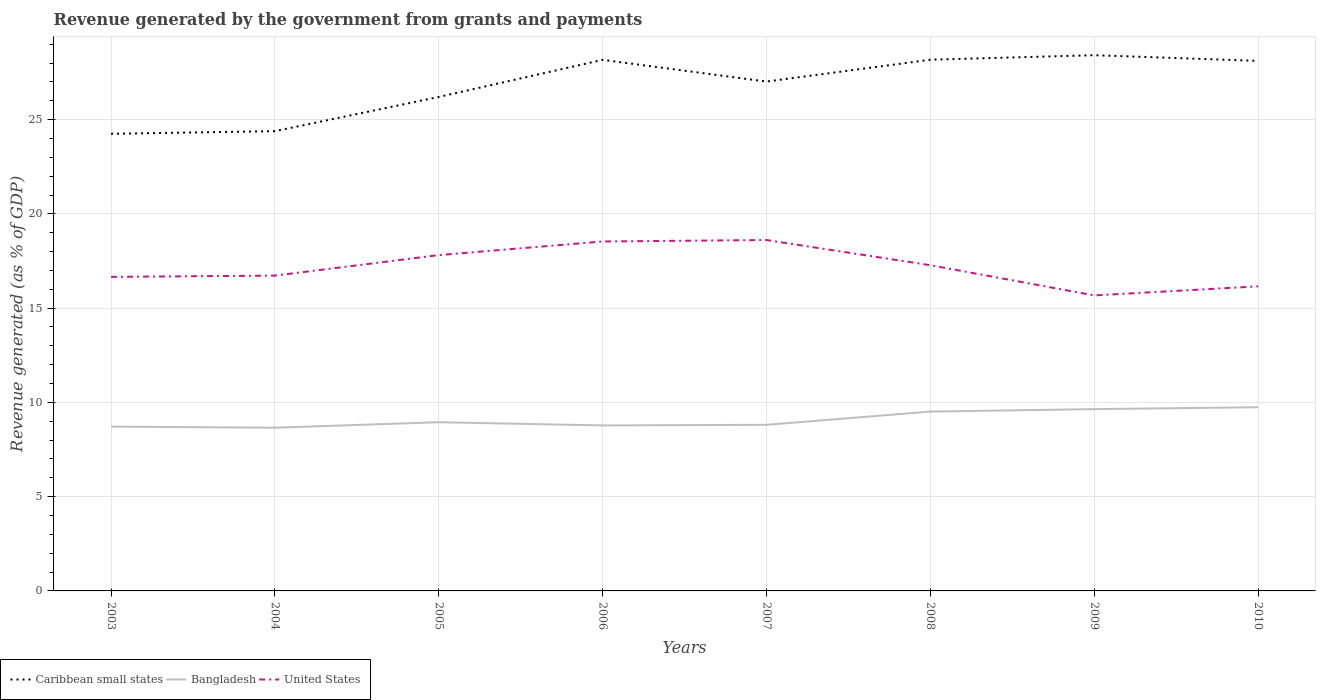How many different coloured lines are there?
Keep it short and to the point. 3. Does the line corresponding to United States intersect with the line corresponding to Caribbean small states?
Provide a short and direct response. No. Is the number of lines equal to the number of legend labels?
Make the answer very short. Yes. Across all years, what is the maximum revenue generated by the government in Caribbean small states?
Offer a very short reply. 24.25. In which year was the revenue generated by the government in Bangladesh maximum?
Ensure brevity in your answer.  2004. What is the total revenue generated by the government in Caribbean small states in the graph?
Your response must be concise. -2.77. What is the difference between the highest and the second highest revenue generated by the government in Bangladesh?
Your answer should be very brief. 1.09. How many years are there in the graph?
Your response must be concise. 8. Are the values on the major ticks of Y-axis written in scientific E-notation?
Provide a succinct answer. No. Does the graph contain any zero values?
Give a very brief answer. No. Where does the legend appear in the graph?
Your response must be concise. Bottom left. How many legend labels are there?
Your answer should be compact. 3. What is the title of the graph?
Give a very brief answer. Revenue generated by the government from grants and payments. What is the label or title of the X-axis?
Your answer should be compact. Years. What is the label or title of the Y-axis?
Give a very brief answer. Revenue generated (as % of GDP). What is the Revenue generated (as % of GDP) in Caribbean small states in 2003?
Provide a short and direct response. 24.25. What is the Revenue generated (as % of GDP) in Bangladesh in 2003?
Ensure brevity in your answer.  8.72. What is the Revenue generated (as % of GDP) in United States in 2003?
Make the answer very short. 16.66. What is the Revenue generated (as % of GDP) of Caribbean small states in 2004?
Keep it short and to the point. 24.39. What is the Revenue generated (as % of GDP) of Bangladesh in 2004?
Provide a short and direct response. 8.66. What is the Revenue generated (as % of GDP) in United States in 2004?
Make the answer very short. 16.73. What is the Revenue generated (as % of GDP) of Caribbean small states in 2005?
Make the answer very short. 26.2. What is the Revenue generated (as % of GDP) in Bangladesh in 2005?
Your response must be concise. 8.95. What is the Revenue generated (as % of GDP) in United States in 2005?
Offer a terse response. 17.81. What is the Revenue generated (as % of GDP) of Caribbean small states in 2006?
Offer a terse response. 28.17. What is the Revenue generated (as % of GDP) of Bangladesh in 2006?
Your answer should be compact. 8.78. What is the Revenue generated (as % of GDP) in United States in 2006?
Provide a succinct answer. 18.54. What is the Revenue generated (as % of GDP) in Caribbean small states in 2007?
Offer a terse response. 27.02. What is the Revenue generated (as % of GDP) of Bangladesh in 2007?
Your response must be concise. 8.81. What is the Revenue generated (as % of GDP) in United States in 2007?
Your answer should be very brief. 18.61. What is the Revenue generated (as % of GDP) of Caribbean small states in 2008?
Provide a succinct answer. 28.18. What is the Revenue generated (as % of GDP) of Bangladesh in 2008?
Make the answer very short. 9.51. What is the Revenue generated (as % of GDP) in United States in 2008?
Offer a terse response. 17.28. What is the Revenue generated (as % of GDP) of Caribbean small states in 2009?
Make the answer very short. 28.42. What is the Revenue generated (as % of GDP) in Bangladesh in 2009?
Offer a terse response. 9.64. What is the Revenue generated (as % of GDP) of United States in 2009?
Your answer should be very brief. 15.68. What is the Revenue generated (as % of GDP) of Caribbean small states in 2010?
Make the answer very short. 28.12. What is the Revenue generated (as % of GDP) of Bangladesh in 2010?
Make the answer very short. 9.74. What is the Revenue generated (as % of GDP) in United States in 2010?
Your response must be concise. 16.16. Across all years, what is the maximum Revenue generated (as % of GDP) of Caribbean small states?
Provide a short and direct response. 28.42. Across all years, what is the maximum Revenue generated (as % of GDP) in Bangladesh?
Offer a terse response. 9.74. Across all years, what is the maximum Revenue generated (as % of GDP) in United States?
Provide a short and direct response. 18.61. Across all years, what is the minimum Revenue generated (as % of GDP) of Caribbean small states?
Your answer should be very brief. 24.25. Across all years, what is the minimum Revenue generated (as % of GDP) of Bangladesh?
Your answer should be very brief. 8.66. Across all years, what is the minimum Revenue generated (as % of GDP) in United States?
Offer a very short reply. 15.68. What is the total Revenue generated (as % of GDP) of Caribbean small states in the graph?
Your response must be concise. 214.74. What is the total Revenue generated (as % of GDP) in Bangladesh in the graph?
Ensure brevity in your answer.  72.81. What is the total Revenue generated (as % of GDP) of United States in the graph?
Ensure brevity in your answer.  137.45. What is the difference between the Revenue generated (as % of GDP) in Caribbean small states in 2003 and that in 2004?
Your response must be concise. -0.14. What is the difference between the Revenue generated (as % of GDP) of Bangladesh in 2003 and that in 2004?
Provide a succinct answer. 0.06. What is the difference between the Revenue generated (as % of GDP) of United States in 2003 and that in 2004?
Your response must be concise. -0.07. What is the difference between the Revenue generated (as % of GDP) in Caribbean small states in 2003 and that in 2005?
Your response must be concise. -1.96. What is the difference between the Revenue generated (as % of GDP) of Bangladesh in 2003 and that in 2005?
Make the answer very short. -0.23. What is the difference between the Revenue generated (as % of GDP) in United States in 2003 and that in 2005?
Make the answer very short. -1.15. What is the difference between the Revenue generated (as % of GDP) in Caribbean small states in 2003 and that in 2006?
Ensure brevity in your answer.  -3.92. What is the difference between the Revenue generated (as % of GDP) in Bangladesh in 2003 and that in 2006?
Provide a succinct answer. -0.06. What is the difference between the Revenue generated (as % of GDP) of United States in 2003 and that in 2006?
Provide a short and direct response. -1.88. What is the difference between the Revenue generated (as % of GDP) of Caribbean small states in 2003 and that in 2007?
Keep it short and to the point. -2.77. What is the difference between the Revenue generated (as % of GDP) in Bangladesh in 2003 and that in 2007?
Ensure brevity in your answer.  -0.1. What is the difference between the Revenue generated (as % of GDP) in United States in 2003 and that in 2007?
Provide a succinct answer. -1.95. What is the difference between the Revenue generated (as % of GDP) of Caribbean small states in 2003 and that in 2008?
Provide a succinct answer. -3.93. What is the difference between the Revenue generated (as % of GDP) of Bangladesh in 2003 and that in 2008?
Your answer should be compact. -0.8. What is the difference between the Revenue generated (as % of GDP) in United States in 2003 and that in 2008?
Offer a terse response. -0.62. What is the difference between the Revenue generated (as % of GDP) of Caribbean small states in 2003 and that in 2009?
Ensure brevity in your answer.  -4.17. What is the difference between the Revenue generated (as % of GDP) in Bangladesh in 2003 and that in 2009?
Keep it short and to the point. -0.93. What is the difference between the Revenue generated (as % of GDP) of Caribbean small states in 2003 and that in 2010?
Keep it short and to the point. -3.87. What is the difference between the Revenue generated (as % of GDP) in Bangladesh in 2003 and that in 2010?
Offer a very short reply. -1.03. What is the difference between the Revenue generated (as % of GDP) of United States in 2003 and that in 2010?
Provide a short and direct response. 0.5. What is the difference between the Revenue generated (as % of GDP) in Caribbean small states in 2004 and that in 2005?
Provide a succinct answer. -1.82. What is the difference between the Revenue generated (as % of GDP) of Bangladesh in 2004 and that in 2005?
Provide a short and direct response. -0.29. What is the difference between the Revenue generated (as % of GDP) of United States in 2004 and that in 2005?
Provide a short and direct response. -1.09. What is the difference between the Revenue generated (as % of GDP) of Caribbean small states in 2004 and that in 2006?
Offer a terse response. -3.78. What is the difference between the Revenue generated (as % of GDP) of Bangladesh in 2004 and that in 2006?
Ensure brevity in your answer.  -0.12. What is the difference between the Revenue generated (as % of GDP) of United States in 2004 and that in 2006?
Keep it short and to the point. -1.81. What is the difference between the Revenue generated (as % of GDP) of Caribbean small states in 2004 and that in 2007?
Keep it short and to the point. -2.63. What is the difference between the Revenue generated (as % of GDP) in Bangladesh in 2004 and that in 2007?
Give a very brief answer. -0.15. What is the difference between the Revenue generated (as % of GDP) of United States in 2004 and that in 2007?
Your response must be concise. -1.89. What is the difference between the Revenue generated (as % of GDP) in Caribbean small states in 2004 and that in 2008?
Provide a short and direct response. -3.79. What is the difference between the Revenue generated (as % of GDP) in Bangladesh in 2004 and that in 2008?
Offer a terse response. -0.86. What is the difference between the Revenue generated (as % of GDP) of United States in 2004 and that in 2008?
Keep it short and to the point. -0.55. What is the difference between the Revenue generated (as % of GDP) of Caribbean small states in 2004 and that in 2009?
Your answer should be compact. -4.03. What is the difference between the Revenue generated (as % of GDP) in Bangladesh in 2004 and that in 2009?
Make the answer very short. -0.99. What is the difference between the Revenue generated (as % of GDP) of United States in 2004 and that in 2009?
Your answer should be compact. 1.05. What is the difference between the Revenue generated (as % of GDP) in Caribbean small states in 2004 and that in 2010?
Ensure brevity in your answer.  -3.73. What is the difference between the Revenue generated (as % of GDP) in Bangladesh in 2004 and that in 2010?
Your answer should be very brief. -1.09. What is the difference between the Revenue generated (as % of GDP) in United States in 2004 and that in 2010?
Your answer should be compact. 0.57. What is the difference between the Revenue generated (as % of GDP) of Caribbean small states in 2005 and that in 2006?
Your answer should be compact. -1.97. What is the difference between the Revenue generated (as % of GDP) in Bangladesh in 2005 and that in 2006?
Ensure brevity in your answer.  0.17. What is the difference between the Revenue generated (as % of GDP) in United States in 2005 and that in 2006?
Ensure brevity in your answer.  -0.72. What is the difference between the Revenue generated (as % of GDP) in Caribbean small states in 2005 and that in 2007?
Your answer should be compact. -0.81. What is the difference between the Revenue generated (as % of GDP) of Bangladesh in 2005 and that in 2007?
Provide a short and direct response. 0.14. What is the difference between the Revenue generated (as % of GDP) in United States in 2005 and that in 2007?
Offer a very short reply. -0.8. What is the difference between the Revenue generated (as % of GDP) in Caribbean small states in 2005 and that in 2008?
Your answer should be compact. -1.97. What is the difference between the Revenue generated (as % of GDP) of Bangladesh in 2005 and that in 2008?
Make the answer very short. -0.56. What is the difference between the Revenue generated (as % of GDP) in United States in 2005 and that in 2008?
Your answer should be compact. 0.54. What is the difference between the Revenue generated (as % of GDP) in Caribbean small states in 2005 and that in 2009?
Keep it short and to the point. -2.21. What is the difference between the Revenue generated (as % of GDP) in Bangladesh in 2005 and that in 2009?
Provide a short and direct response. -0.69. What is the difference between the Revenue generated (as % of GDP) of United States in 2005 and that in 2009?
Your answer should be compact. 2.14. What is the difference between the Revenue generated (as % of GDP) of Caribbean small states in 2005 and that in 2010?
Your response must be concise. -1.91. What is the difference between the Revenue generated (as % of GDP) of Bangladesh in 2005 and that in 2010?
Your answer should be very brief. -0.79. What is the difference between the Revenue generated (as % of GDP) in United States in 2005 and that in 2010?
Your answer should be compact. 1.66. What is the difference between the Revenue generated (as % of GDP) of Caribbean small states in 2006 and that in 2007?
Your answer should be very brief. 1.15. What is the difference between the Revenue generated (as % of GDP) of Bangladesh in 2006 and that in 2007?
Your answer should be compact. -0.03. What is the difference between the Revenue generated (as % of GDP) in United States in 2006 and that in 2007?
Keep it short and to the point. -0.08. What is the difference between the Revenue generated (as % of GDP) of Caribbean small states in 2006 and that in 2008?
Your answer should be very brief. -0.01. What is the difference between the Revenue generated (as % of GDP) in Bangladesh in 2006 and that in 2008?
Give a very brief answer. -0.73. What is the difference between the Revenue generated (as % of GDP) of United States in 2006 and that in 2008?
Your answer should be very brief. 1.26. What is the difference between the Revenue generated (as % of GDP) of Caribbean small states in 2006 and that in 2009?
Keep it short and to the point. -0.25. What is the difference between the Revenue generated (as % of GDP) of Bangladesh in 2006 and that in 2009?
Your answer should be very brief. -0.86. What is the difference between the Revenue generated (as % of GDP) in United States in 2006 and that in 2009?
Your response must be concise. 2.86. What is the difference between the Revenue generated (as % of GDP) in Caribbean small states in 2006 and that in 2010?
Ensure brevity in your answer.  0.05. What is the difference between the Revenue generated (as % of GDP) of Bangladesh in 2006 and that in 2010?
Offer a very short reply. -0.97. What is the difference between the Revenue generated (as % of GDP) in United States in 2006 and that in 2010?
Give a very brief answer. 2.38. What is the difference between the Revenue generated (as % of GDP) of Caribbean small states in 2007 and that in 2008?
Offer a very short reply. -1.16. What is the difference between the Revenue generated (as % of GDP) in Bangladesh in 2007 and that in 2008?
Offer a terse response. -0.7. What is the difference between the Revenue generated (as % of GDP) of United States in 2007 and that in 2008?
Your response must be concise. 1.34. What is the difference between the Revenue generated (as % of GDP) in Caribbean small states in 2007 and that in 2009?
Ensure brevity in your answer.  -1.4. What is the difference between the Revenue generated (as % of GDP) in Bangladesh in 2007 and that in 2009?
Give a very brief answer. -0.83. What is the difference between the Revenue generated (as % of GDP) in United States in 2007 and that in 2009?
Give a very brief answer. 2.94. What is the difference between the Revenue generated (as % of GDP) in Caribbean small states in 2007 and that in 2010?
Provide a succinct answer. -1.1. What is the difference between the Revenue generated (as % of GDP) of Bangladesh in 2007 and that in 2010?
Your answer should be very brief. -0.93. What is the difference between the Revenue generated (as % of GDP) in United States in 2007 and that in 2010?
Provide a short and direct response. 2.46. What is the difference between the Revenue generated (as % of GDP) of Caribbean small states in 2008 and that in 2009?
Give a very brief answer. -0.24. What is the difference between the Revenue generated (as % of GDP) in Bangladesh in 2008 and that in 2009?
Offer a very short reply. -0.13. What is the difference between the Revenue generated (as % of GDP) of United States in 2008 and that in 2009?
Your response must be concise. 1.6. What is the difference between the Revenue generated (as % of GDP) of Caribbean small states in 2008 and that in 2010?
Your answer should be very brief. 0.06. What is the difference between the Revenue generated (as % of GDP) in Bangladesh in 2008 and that in 2010?
Give a very brief answer. -0.23. What is the difference between the Revenue generated (as % of GDP) of United States in 2008 and that in 2010?
Give a very brief answer. 1.12. What is the difference between the Revenue generated (as % of GDP) in Caribbean small states in 2009 and that in 2010?
Give a very brief answer. 0.3. What is the difference between the Revenue generated (as % of GDP) in Bangladesh in 2009 and that in 2010?
Provide a short and direct response. -0.1. What is the difference between the Revenue generated (as % of GDP) of United States in 2009 and that in 2010?
Offer a terse response. -0.48. What is the difference between the Revenue generated (as % of GDP) of Caribbean small states in 2003 and the Revenue generated (as % of GDP) of Bangladesh in 2004?
Make the answer very short. 15.59. What is the difference between the Revenue generated (as % of GDP) of Caribbean small states in 2003 and the Revenue generated (as % of GDP) of United States in 2004?
Ensure brevity in your answer.  7.52. What is the difference between the Revenue generated (as % of GDP) in Bangladesh in 2003 and the Revenue generated (as % of GDP) in United States in 2004?
Your answer should be compact. -8.01. What is the difference between the Revenue generated (as % of GDP) in Caribbean small states in 2003 and the Revenue generated (as % of GDP) in Bangladesh in 2005?
Your answer should be very brief. 15.3. What is the difference between the Revenue generated (as % of GDP) of Caribbean small states in 2003 and the Revenue generated (as % of GDP) of United States in 2005?
Your response must be concise. 6.44. What is the difference between the Revenue generated (as % of GDP) in Bangladesh in 2003 and the Revenue generated (as % of GDP) in United States in 2005?
Provide a succinct answer. -9.1. What is the difference between the Revenue generated (as % of GDP) of Caribbean small states in 2003 and the Revenue generated (as % of GDP) of Bangladesh in 2006?
Provide a succinct answer. 15.47. What is the difference between the Revenue generated (as % of GDP) in Caribbean small states in 2003 and the Revenue generated (as % of GDP) in United States in 2006?
Ensure brevity in your answer.  5.71. What is the difference between the Revenue generated (as % of GDP) of Bangladesh in 2003 and the Revenue generated (as % of GDP) of United States in 2006?
Ensure brevity in your answer.  -9.82. What is the difference between the Revenue generated (as % of GDP) of Caribbean small states in 2003 and the Revenue generated (as % of GDP) of Bangladesh in 2007?
Ensure brevity in your answer.  15.44. What is the difference between the Revenue generated (as % of GDP) in Caribbean small states in 2003 and the Revenue generated (as % of GDP) in United States in 2007?
Your answer should be compact. 5.64. What is the difference between the Revenue generated (as % of GDP) of Bangladesh in 2003 and the Revenue generated (as % of GDP) of United States in 2007?
Provide a short and direct response. -9.9. What is the difference between the Revenue generated (as % of GDP) of Caribbean small states in 2003 and the Revenue generated (as % of GDP) of Bangladesh in 2008?
Give a very brief answer. 14.74. What is the difference between the Revenue generated (as % of GDP) of Caribbean small states in 2003 and the Revenue generated (as % of GDP) of United States in 2008?
Offer a terse response. 6.97. What is the difference between the Revenue generated (as % of GDP) in Bangladesh in 2003 and the Revenue generated (as % of GDP) in United States in 2008?
Provide a short and direct response. -8.56. What is the difference between the Revenue generated (as % of GDP) in Caribbean small states in 2003 and the Revenue generated (as % of GDP) in Bangladesh in 2009?
Offer a very short reply. 14.61. What is the difference between the Revenue generated (as % of GDP) in Caribbean small states in 2003 and the Revenue generated (as % of GDP) in United States in 2009?
Offer a terse response. 8.57. What is the difference between the Revenue generated (as % of GDP) of Bangladesh in 2003 and the Revenue generated (as % of GDP) of United States in 2009?
Your answer should be compact. -6.96. What is the difference between the Revenue generated (as % of GDP) of Caribbean small states in 2003 and the Revenue generated (as % of GDP) of Bangladesh in 2010?
Provide a succinct answer. 14.5. What is the difference between the Revenue generated (as % of GDP) of Caribbean small states in 2003 and the Revenue generated (as % of GDP) of United States in 2010?
Your answer should be very brief. 8.09. What is the difference between the Revenue generated (as % of GDP) in Bangladesh in 2003 and the Revenue generated (as % of GDP) in United States in 2010?
Your response must be concise. -7.44. What is the difference between the Revenue generated (as % of GDP) in Caribbean small states in 2004 and the Revenue generated (as % of GDP) in Bangladesh in 2005?
Your answer should be compact. 15.44. What is the difference between the Revenue generated (as % of GDP) of Caribbean small states in 2004 and the Revenue generated (as % of GDP) of United States in 2005?
Ensure brevity in your answer.  6.57. What is the difference between the Revenue generated (as % of GDP) of Bangladesh in 2004 and the Revenue generated (as % of GDP) of United States in 2005?
Provide a succinct answer. -9.16. What is the difference between the Revenue generated (as % of GDP) in Caribbean small states in 2004 and the Revenue generated (as % of GDP) in Bangladesh in 2006?
Keep it short and to the point. 15.61. What is the difference between the Revenue generated (as % of GDP) of Caribbean small states in 2004 and the Revenue generated (as % of GDP) of United States in 2006?
Ensure brevity in your answer.  5.85. What is the difference between the Revenue generated (as % of GDP) of Bangladesh in 2004 and the Revenue generated (as % of GDP) of United States in 2006?
Your answer should be very brief. -9.88. What is the difference between the Revenue generated (as % of GDP) of Caribbean small states in 2004 and the Revenue generated (as % of GDP) of Bangladesh in 2007?
Give a very brief answer. 15.58. What is the difference between the Revenue generated (as % of GDP) in Caribbean small states in 2004 and the Revenue generated (as % of GDP) in United States in 2007?
Your answer should be very brief. 5.78. What is the difference between the Revenue generated (as % of GDP) in Bangladesh in 2004 and the Revenue generated (as % of GDP) in United States in 2007?
Make the answer very short. -9.96. What is the difference between the Revenue generated (as % of GDP) of Caribbean small states in 2004 and the Revenue generated (as % of GDP) of Bangladesh in 2008?
Your answer should be very brief. 14.87. What is the difference between the Revenue generated (as % of GDP) in Caribbean small states in 2004 and the Revenue generated (as % of GDP) in United States in 2008?
Your answer should be compact. 7.11. What is the difference between the Revenue generated (as % of GDP) of Bangladesh in 2004 and the Revenue generated (as % of GDP) of United States in 2008?
Offer a very short reply. -8.62. What is the difference between the Revenue generated (as % of GDP) of Caribbean small states in 2004 and the Revenue generated (as % of GDP) of Bangladesh in 2009?
Offer a terse response. 14.74. What is the difference between the Revenue generated (as % of GDP) of Caribbean small states in 2004 and the Revenue generated (as % of GDP) of United States in 2009?
Provide a succinct answer. 8.71. What is the difference between the Revenue generated (as % of GDP) of Bangladesh in 2004 and the Revenue generated (as % of GDP) of United States in 2009?
Offer a terse response. -7.02. What is the difference between the Revenue generated (as % of GDP) in Caribbean small states in 2004 and the Revenue generated (as % of GDP) in Bangladesh in 2010?
Your answer should be compact. 14.64. What is the difference between the Revenue generated (as % of GDP) in Caribbean small states in 2004 and the Revenue generated (as % of GDP) in United States in 2010?
Give a very brief answer. 8.23. What is the difference between the Revenue generated (as % of GDP) in Bangladesh in 2004 and the Revenue generated (as % of GDP) in United States in 2010?
Ensure brevity in your answer.  -7.5. What is the difference between the Revenue generated (as % of GDP) in Caribbean small states in 2005 and the Revenue generated (as % of GDP) in Bangladesh in 2006?
Offer a terse response. 17.43. What is the difference between the Revenue generated (as % of GDP) in Caribbean small states in 2005 and the Revenue generated (as % of GDP) in United States in 2006?
Give a very brief answer. 7.67. What is the difference between the Revenue generated (as % of GDP) in Bangladesh in 2005 and the Revenue generated (as % of GDP) in United States in 2006?
Your answer should be very brief. -9.59. What is the difference between the Revenue generated (as % of GDP) of Caribbean small states in 2005 and the Revenue generated (as % of GDP) of Bangladesh in 2007?
Your answer should be compact. 17.39. What is the difference between the Revenue generated (as % of GDP) in Caribbean small states in 2005 and the Revenue generated (as % of GDP) in United States in 2007?
Your response must be concise. 7.59. What is the difference between the Revenue generated (as % of GDP) in Bangladesh in 2005 and the Revenue generated (as % of GDP) in United States in 2007?
Provide a succinct answer. -9.66. What is the difference between the Revenue generated (as % of GDP) of Caribbean small states in 2005 and the Revenue generated (as % of GDP) of Bangladesh in 2008?
Ensure brevity in your answer.  16.69. What is the difference between the Revenue generated (as % of GDP) in Caribbean small states in 2005 and the Revenue generated (as % of GDP) in United States in 2008?
Your response must be concise. 8.93. What is the difference between the Revenue generated (as % of GDP) of Bangladesh in 2005 and the Revenue generated (as % of GDP) of United States in 2008?
Your answer should be very brief. -8.33. What is the difference between the Revenue generated (as % of GDP) of Caribbean small states in 2005 and the Revenue generated (as % of GDP) of Bangladesh in 2009?
Provide a short and direct response. 16.56. What is the difference between the Revenue generated (as % of GDP) in Caribbean small states in 2005 and the Revenue generated (as % of GDP) in United States in 2009?
Your response must be concise. 10.53. What is the difference between the Revenue generated (as % of GDP) in Bangladesh in 2005 and the Revenue generated (as % of GDP) in United States in 2009?
Ensure brevity in your answer.  -6.73. What is the difference between the Revenue generated (as % of GDP) of Caribbean small states in 2005 and the Revenue generated (as % of GDP) of Bangladesh in 2010?
Offer a terse response. 16.46. What is the difference between the Revenue generated (as % of GDP) in Caribbean small states in 2005 and the Revenue generated (as % of GDP) in United States in 2010?
Your answer should be very brief. 10.05. What is the difference between the Revenue generated (as % of GDP) of Bangladesh in 2005 and the Revenue generated (as % of GDP) of United States in 2010?
Provide a succinct answer. -7.21. What is the difference between the Revenue generated (as % of GDP) in Caribbean small states in 2006 and the Revenue generated (as % of GDP) in Bangladesh in 2007?
Ensure brevity in your answer.  19.36. What is the difference between the Revenue generated (as % of GDP) of Caribbean small states in 2006 and the Revenue generated (as % of GDP) of United States in 2007?
Your answer should be compact. 9.56. What is the difference between the Revenue generated (as % of GDP) of Bangladesh in 2006 and the Revenue generated (as % of GDP) of United States in 2007?
Your response must be concise. -9.83. What is the difference between the Revenue generated (as % of GDP) of Caribbean small states in 2006 and the Revenue generated (as % of GDP) of Bangladesh in 2008?
Give a very brief answer. 18.66. What is the difference between the Revenue generated (as % of GDP) of Caribbean small states in 2006 and the Revenue generated (as % of GDP) of United States in 2008?
Provide a short and direct response. 10.89. What is the difference between the Revenue generated (as % of GDP) in Bangladesh in 2006 and the Revenue generated (as % of GDP) in United States in 2008?
Your response must be concise. -8.5. What is the difference between the Revenue generated (as % of GDP) of Caribbean small states in 2006 and the Revenue generated (as % of GDP) of Bangladesh in 2009?
Your answer should be compact. 18.53. What is the difference between the Revenue generated (as % of GDP) in Caribbean small states in 2006 and the Revenue generated (as % of GDP) in United States in 2009?
Offer a terse response. 12.49. What is the difference between the Revenue generated (as % of GDP) in Bangladesh in 2006 and the Revenue generated (as % of GDP) in United States in 2009?
Keep it short and to the point. -6.9. What is the difference between the Revenue generated (as % of GDP) in Caribbean small states in 2006 and the Revenue generated (as % of GDP) in Bangladesh in 2010?
Your answer should be compact. 18.43. What is the difference between the Revenue generated (as % of GDP) in Caribbean small states in 2006 and the Revenue generated (as % of GDP) in United States in 2010?
Provide a short and direct response. 12.01. What is the difference between the Revenue generated (as % of GDP) of Bangladesh in 2006 and the Revenue generated (as % of GDP) of United States in 2010?
Your answer should be compact. -7.38. What is the difference between the Revenue generated (as % of GDP) in Caribbean small states in 2007 and the Revenue generated (as % of GDP) in Bangladesh in 2008?
Keep it short and to the point. 17.51. What is the difference between the Revenue generated (as % of GDP) of Caribbean small states in 2007 and the Revenue generated (as % of GDP) of United States in 2008?
Your response must be concise. 9.74. What is the difference between the Revenue generated (as % of GDP) of Bangladesh in 2007 and the Revenue generated (as % of GDP) of United States in 2008?
Offer a terse response. -8.47. What is the difference between the Revenue generated (as % of GDP) of Caribbean small states in 2007 and the Revenue generated (as % of GDP) of Bangladesh in 2009?
Keep it short and to the point. 17.38. What is the difference between the Revenue generated (as % of GDP) of Caribbean small states in 2007 and the Revenue generated (as % of GDP) of United States in 2009?
Ensure brevity in your answer.  11.34. What is the difference between the Revenue generated (as % of GDP) in Bangladesh in 2007 and the Revenue generated (as % of GDP) in United States in 2009?
Ensure brevity in your answer.  -6.86. What is the difference between the Revenue generated (as % of GDP) in Caribbean small states in 2007 and the Revenue generated (as % of GDP) in Bangladesh in 2010?
Ensure brevity in your answer.  17.27. What is the difference between the Revenue generated (as % of GDP) in Caribbean small states in 2007 and the Revenue generated (as % of GDP) in United States in 2010?
Ensure brevity in your answer.  10.86. What is the difference between the Revenue generated (as % of GDP) in Bangladesh in 2007 and the Revenue generated (as % of GDP) in United States in 2010?
Your response must be concise. -7.35. What is the difference between the Revenue generated (as % of GDP) of Caribbean small states in 2008 and the Revenue generated (as % of GDP) of Bangladesh in 2009?
Offer a terse response. 18.53. What is the difference between the Revenue generated (as % of GDP) of Caribbean small states in 2008 and the Revenue generated (as % of GDP) of United States in 2009?
Provide a short and direct response. 12.5. What is the difference between the Revenue generated (as % of GDP) in Bangladesh in 2008 and the Revenue generated (as % of GDP) in United States in 2009?
Your answer should be very brief. -6.16. What is the difference between the Revenue generated (as % of GDP) of Caribbean small states in 2008 and the Revenue generated (as % of GDP) of Bangladesh in 2010?
Your answer should be compact. 18.43. What is the difference between the Revenue generated (as % of GDP) of Caribbean small states in 2008 and the Revenue generated (as % of GDP) of United States in 2010?
Your answer should be very brief. 12.02. What is the difference between the Revenue generated (as % of GDP) in Bangladesh in 2008 and the Revenue generated (as % of GDP) in United States in 2010?
Ensure brevity in your answer.  -6.64. What is the difference between the Revenue generated (as % of GDP) of Caribbean small states in 2009 and the Revenue generated (as % of GDP) of Bangladesh in 2010?
Give a very brief answer. 18.67. What is the difference between the Revenue generated (as % of GDP) of Caribbean small states in 2009 and the Revenue generated (as % of GDP) of United States in 2010?
Your answer should be very brief. 12.26. What is the difference between the Revenue generated (as % of GDP) in Bangladesh in 2009 and the Revenue generated (as % of GDP) in United States in 2010?
Offer a terse response. -6.51. What is the average Revenue generated (as % of GDP) in Caribbean small states per year?
Keep it short and to the point. 26.84. What is the average Revenue generated (as % of GDP) in Bangladesh per year?
Keep it short and to the point. 9.1. What is the average Revenue generated (as % of GDP) in United States per year?
Give a very brief answer. 17.18. In the year 2003, what is the difference between the Revenue generated (as % of GDP) of Caribbean small states and Revenue generated (as % of GDP) of Bangladesh?
Offer a very short reply. 15.53. In the year 2003, what is the difference between the Revenue generated (as % of GDP) of Caribbean small states and Revenue generated (as % of GDP) of United States?
Your answer should be compact. 7.59. In the year 2003, what is the difference between the Revenue generated (as % of GDP) in Bangladesh and Revenue generated (as % of GDP) in United States?
Provide a succinct answer. -7.94. In the year 2004, what is the difference between the Revenue generated (as % of GDP) of Caribbean small states and Revenue generated (as % of GDP) of Bangladesh?
Your answer should be very brief. 15.73. In the year 2004, what is the difference between the Revenue generated (as % of GDP) in Caribbean small states and Revenue generated (as % of GDP) in United States?
Make the answer very short. 7.66. In the year 2004, what is the difference between the Revenue generated (as % of GDP) of Bangladesh and Revenue generated (as % of GDP) of United States?
Provide a succinct answer. -8.07. In the year 2005, what is the difference between the Revenue generated (as % of GDP) of Caribbean small states and Revenue generated (as % of GDP) of Bangladesh?
Your answer should be very brief. 17.25. In the year 2005, what is the difference between the Revenue generated (as % of GDP) in Caribbean small states and Revenue generated (as % of GDP) in United States?
Ensure brevity in your answer.  8.39. In the year 2005, what is the difference between the Revenue generated (as % of GDP) in Bangladesh and Revenue generated (as % of GDP) in United States?
Ensure brevity in your answer.  -8.86. In the year 2006, what is the difference between the Revenue generated (as % of GDP) of Caribbean small states and Revenue generated (as % of GDP) of Bangladesh?
Ensure brevity in your answer.  19.39. In the year 2006, what is the difference between the Revenue generated (as % of GDP) of Caribbean small states and Revenue generated (as % of GDP) of United States?
Provide a succinct answer. 9.63. In the year 2006, what is the difference between the Revenue generated (as % of GDP) of Bangladesh and Revenue generated (as % of GDP) of United States?
Keep it short and to the point. -9.76. In the year 2007, what is the difference between the Revenue generated (as % of GDP) of Caribbean small states and Revenue generated (as % of GDP) of Bangladesh?
Keep it short and to the point. 18.21. In the year 2007, what is the difference between the Revenue generated (as % of GDP) in Caribbean small states and Revenue generated (as % of GDP) in United States?
Your response must be concise. 8.41. In the year 2007, what is the difference between the Revenue generated (as % of GDP) of Bangladesh and Revenue generated (as % of GDP) of United States?
Keep it short and to the point. -9.8. In the year 2008, what is the difference between the Revenue generated (as % of GDP) in Caribbean small states and Revenue generated (as % of GDP) in Bangladesh?
Provide a succinct answer. 18.66. In the year 2008, what is the difference between the Revenue generated (as % of GDP) of Caribbean small states and Revenue generated (as % of GDP) of United States?
Offer a very short reply. 10.9. In the year 2008, what is the difference between the Revenue generated (as % of GDP) in Bangladesh and Revenue generated (as % of GDP) in United States?
Give a very brief answer. -7.76. In the year 2009, what is the difference between the Revenue generated (as % of GDP) of Caribbean small states and Revenue generated (as % of GDP) of Bangladesh?
Give a very brief answer. 18.77. In the year 2009, what is the difference between the Revenue generated (as % of GDP) of Caribbean small states and Revenue generated (as % of GDP) of United States?
Offer a very short reply. 12.74. In the year 2009, what is the difference between the Revenue generated (as % of GDP) in Bangladesh and Revenue generated (as % of GDP) in United States?
Give a very brief answer. -6.03. In the year 2010, what is the difference between the Revenue generated (as % of GDP) of Caribbean small states and Revenue generated (as % of GDP) of Bangladesh?
Your answer should be very brief. 18.37. In the year 2010, what is the difference between the Revenue generated (as % of GDP) of Caribbean small states and Revenue generated (as % of GDP) of United States?
Keep it short and to the point. 11.96. In the year 2010, what is the difference between the Revenue generated (as % of GDP) in Bangladesh and Revenue generated (as % of GDP) in United States?
Keep it short and to the point. -6.41. What is the ratio of the Revenue generated (as % of GDP) in Bangladesh in 2003 to that in 2004?
Provide a succinct answer. 1.01. What is the ratio of the Revenue generated (as % of GDP) of Caribbean small states in 2003 to that in 2005?
Your answer should be compact. 0.93. What is the ratio of the Revenue generated (as % of GDP) in Bangladesh in 2003 to that in 2005?
Provide a succinct answer. 0.97. What is the ratio of the Revenue generated (as % of GDP) of United States in 2003 to that in 2005?
Offer a terse response. 0.94. What is the ratio of the Revenue generated (as % of GDP) of Caribbean small states in 2003 to that in 2006?
Provide a succinct answer. 0.86. What is the ratio of the Revenue generated (as % of GDP) of United States in 2003 to that in 2006?
Keep it short and to the point. 0.9. What is the ratio of the Revenue generated (as % of GDP) in Caribbean small states in 2003 to that in 2007?
Provide a short and direct response. 0.9. What is the ratio of the Revenue generated (as % of GDP) in Bangladesh in 2003 to that in 2007?
Ensure brevity in your answer.  0.99. What is the ratio of the Revenue generated (as % of GDP) of United States in 2003 to that in 2007?
Provide a short and direct response. 0.9. What is the ratio of the Revenue generated (as % of GDP) in Caribbean small states in 2003 to that in 2008?
Offer a terse response. 0.86. What is the ratio of the Revenue generated (as % of GDP) in Bangladesh in 2003 to that in 2008?
Your response must be concise. 0.92. What is the ratio of the Revenue generated (as % of GDP) in United States in 2003 to that in 2008?
Your answer should be very brief. 0.96. What is the ratio of the Revenue generated (as % of GDP) of Caribbean small states in 2003 to that in 2009?
Make the answer very short. 0.85. What is the ratio of the Revenue generated (as % of GDP) of Bangladesh in 2003 to that in 2009?
Offer a very short reply. 0.9. What is the ratio of the Revenue generated (as % of GDP) of United States in 2003 to that in 2009?
Offer a very short reply. 1.06. What is the ratio of the Revenue generated (as % of GDP) in Caribbean small states in 2003 to that in 2010?
Your response must be concise. 0.86. What is the ratio of the Revenue generated (as % of GDP) in Bangladesh in 2003 to that in 2010?
Provide a short and direct response. 0.89. What is the ratio of the Revenue generated (as % of GDP) of United States in 2003 to that in 2010?
Offer a terse response. 1.03. What is the ratio of the Revenue generated (as % of GDP) in Caribbean small states in 2004 to that in 2005?
Make the answer very short. 0.93. What is the ratio of the Revenue generated (as % of GDP) in Bangladesh in 2004 to that in 2005?
Your response must be concise. 0.97. What is the ratio of the Revenue generated (as % of GDP) in United States in 2004 to that in 2005?
Your answer should be very brief. 0.94. What is the ratio of the Revenue generated (as % of GDP) in Caribbean small states in 2004 to that in 2006?
Your response must be concise. 0.87. What is the ratio of the Revenue generated (as % of GDP) of Bangladesh in 2004 to that in 2006?
Your answer should be very brief. 0.99. What is the ratio of the Revenue generated (as % of GDP) of United States in 2004 to that in 2006?
Provide a succinct answer. 0.9. What is the ratio of the Revenue generated (as % of GDP) in Caribbean small states in 2004 to that in 2007?
Give a very brief answer. 0.9. What is the ratio of the Revenue generated (as % of GDP) in Bangladesh in 2004 to that in 2007?
Your response must be concise. 0.98. What is the ratio of the Revenue generated (as % of GDP) in United States in 2004 to that in 2007?
Offer a very short reply. 0.9. What is the ratio of the Revenue generated (as % of GDP) of Caribbean small states in 2004 to that in 2008?
Your answer should be compact. 0.87. What is the ratio of the Revenue generated (as % of GDP) of Bangladesh in 2004 to that in 2008?
Your answer should be compact. 0.91. What is the ratio of the Revenue generated (as % of GDP) of United States in 2004 to that in 2008?
Give a very brief answer. 0.97. What is the ratio of the Revenue generated (as % of GDP) of Caribbean small states in 2004 to that in 2009?
Provide a succinct answer. 0.86. What is the ratio of the Revenue generated (as % of GDP) in Bangladesh in 2004 to that in 2009?
Your answer should be compact. 0.9. What is the ratio of the Revenue generated (as % of GDP) of United States in 2004 to that in 2009?
Your response must be concise. 1.07. What is the ratio of the Revenue generated (as % of GDP) of Caribbean small states in 2004 to that in 2010?
Your response must be concise. 0.87. What is the ratio of the Revenue generated (as % of GDP) in Bangladesh in 2004 to that in 2010?
Offer a terse response. 0.89. What is the ratio of the Revenue generated (as % of GDP) of United States in 2004 to that in 2010?
Offer a terse response. 1.04. What is the ratio of the Revenue generated (as % of GDP) of Caribbean small states in 2005 to that in 2006?
Provide a short and direct response. 0.93. What is the ratio of the Revenue generated (as % of GDP) of Bangladesh in 2005 to that in 2006?
Offer a very short reply. 1.02. What is the ratio of the Revenue generated (as % of GDP) of United States in 2005 to that in 2006?
Your response must be concise. 0.96. What is the ratio of the Revenue generated (as % of GDP) in Caribbean small states in 2005 to that in 2007?
Your answer should be very brief. 0.97. What is the ratio of the Revenue generated (as % of GDP) in Bangladesh in 2005 to that in 2007?
Give a very brief answer. 1.02. What is the ratio of the Revenue generated (as % of GDP) in United States in 2005 to that in 2007?
Your answer should be compact. 0.96. What is the ratio of the Revenue generated (as % of GDP) in Caribbean small states in 2005 to that in 2008?
Keep it short and to the point. 0.93. What is the ratio of the Revenue generated (as % of GDP) of Bangladesh in 2005 to that in 2008?
Offer a very short reply. 0.94. What is the ratio of the Revenue generated (as % of GDP) in United States in 2005 to that in 2008?
Your response must be concise. 1.03. What is the ratio of the Revenue generated (as % of GDP) in Caribbean small states in 2005 to that in 2009?
Your answer should be compact. 0.92. What is the ratio of the Revenue generated (as % of GDP) of Bangladesh in 2005 to that in 2009?
Keep it short and to the point. 0.93. What is the ratio of the Revenue generated (as % of GDP) in United States in 2005 to that in 2009?
Keep it short and to the point. 1.14. What is the ratio of the Revenue generated (as % of GDP) in Caribbean small states in 2005 to that in 2010?
Your answer should be very brief. 0.93. What is the ratio of the Revenue generated (as % of GDP) in Bangladesh in 2005 to that in 2010?
Provide a short and direct response. 0.92. What is the ratio of the Revenue generated (as % of GDP) of United States in 2005 to that in 2010?
Your answer should be compact. 1.1. What is the ratio of the Revenue generated (as % of GDP) in Caribbean small states in 2006 to that in 2007?
Your response must be concise. 1.04. What is the ratio of the Revenue generated (as % of GDP) of United States in 2006 to that in 2007?
Provide a succinct answer. 1. What is the ratio of the Revenue generated (as % of GDP) in Caribbean small states in 2006 to that in 2008?
Provide a short and direct response. 1. What is the ratio of the Revenue generated (as % of GDP) in Bangladesh in 2006 to that in 2008?
Provide a short and direct response. 0.92. What is the ratio of the Revenue generated (as % of GDP) of United States in 2006 to that in 2008?
Provide a succinct answer. 1.07. What is the ratio of the Revenue generated (as % of GDP) in Bangladesh in 2006 to that in 2009?
Your response must be concise. 0.91. What is the ratio of the Revenue generated (as % of GDP) of United States in 2006 to that in 2009?
Your answer should be very brief. 1.18. What is the ratio of the Revenue generated (as % of GDP) in Bangladesh in 2006 to that in 2010?
Offer a terse response. 0.9. What is the ratio of the Revenue generated (as % of GDP) in United States in 2006 to that in 2010?
Give a very brief answer. 1.15. What is the ratio of the Revenue generated (as % of GDP) in Caribbean small states in 2007 to that in 2008?
Your answer should be very brief. 0.96. What is the ratio of the Revenue generated (as % of GDP) in Bangladesh in 2007 to that in 2008?
Offer a very short reply. 0.93. What is the ratio of the Revenue generated (as % of GDP) in United States in 2007 to that in 2008?
Offer a terse response. 1.08. What is the ratio of the Revenue generated (as % of GDP) in Caribbean small states in 2007 to that in 2009?
Offer a very short reply. 0.95. What is the ratio of the Revenue generated (as % of GDP) of Bangladesh in 2007 to that in 2009?
Provide a short and direct response. 0.91. What is the ratio of the Revenue generated (as % of GDP) in United States in 2007 to that in 2009?
Your answer should be very brief. 1.19. What is the ratio of the Revenue generated (as % of GDP) in Bangladesh in 2007 to that in 2010?
Offer a terse response. 0.9. What is the ratio of the Revenue generated (as % of GDP) of United States in 2007 to that in 2010?
Offer a very short reply. 1.15. What is the ratio of the Revenue generated (as % of GDP) of Caribbean small states in 2008 to that in 2009?
Your answer should be very brief. 0.99. What is the ratio of the Revenue generated (as % of GDP) in Bangladesh in 2008 to that in 2009?
Provide a succinct answer. 0.99. What is the ratio of the Revenue generated (as % of GDP) in United States in 2008 to that in 2009?
Ensure brevity in your answer.  1.1. What is the ratio of the Revenue generated (as % of GDP) in Bangladesh in 2008 to that in 2010?
Ensure brevity in your answer.  0.98. What is the ratio of the Revenue generated (as % of GDP) of United States in 2008 to that in 2010?
Your answer should be very brief. 1.07. What is the ratio of the Revenue generated (as % of GDP) of Caribbean small states in 2009 to that in 2010?
Ensure brevity in your answer.  1.01. What is the ratio of the Revenue generated (as % of GDP) of Bangladesh in 2009 to that in 2010?
Your answer should be compact. 0.99. What is the ratio of the Revenue generated (as % of GDP) of United States in 2009 to that in 2010?
Ensure brevity in your answer.  0.97. What is the difference between the highest and the second highest Revenue generated (as % of GDP) in Caribbean small states?
Make the answer very short. 0.24. What is the difference between the highest and the second highest Revenue generated (as % of GDP) in Bangladesh?
Give a very brief answer. 0.1. What is the difference between the highest and the second highest Revenue generated (as % of GDP) in United States?
Provide a succinct answer. 0.08. What is the difference between the highest and the lowest Revenue generated (as % of GDP) in Caribbean small states?
Offer a very short reply. 4.17. What is the difference between the highest and the lowest Revenue generated (as % of GDP) in Bangladesh?
Provide a short and direct response. 1.09. What is the difference between the highest and the lowest Revenue generated (as % of GDP) of United States?
Provide a short and direct response. 2.94. 